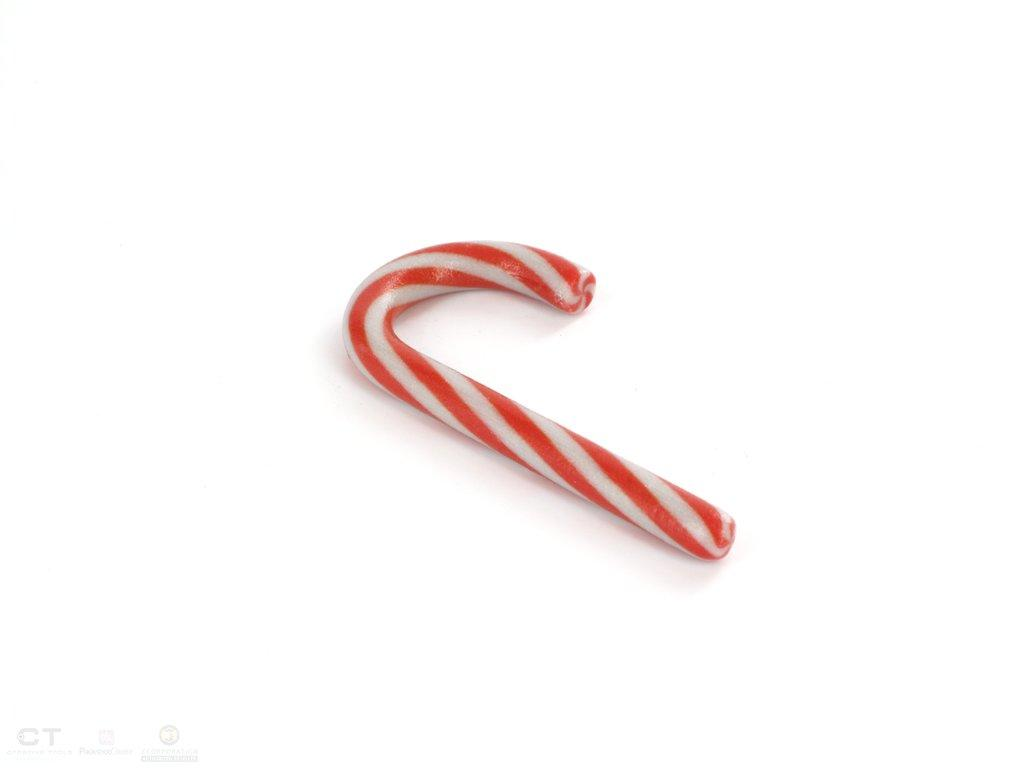What type of candy is in the image? There is sugar candy in the image. What colors are the sugar candy? The sugar candy is in red and white color. What grade does the airport receive for its customer service in the image? There is no airport or mention of customer service in the image, so it is not possible to answer that question. 